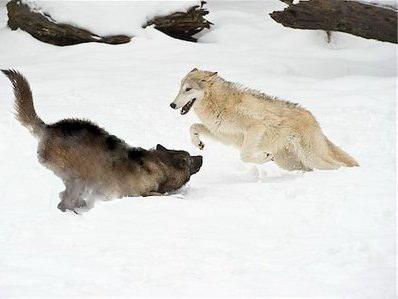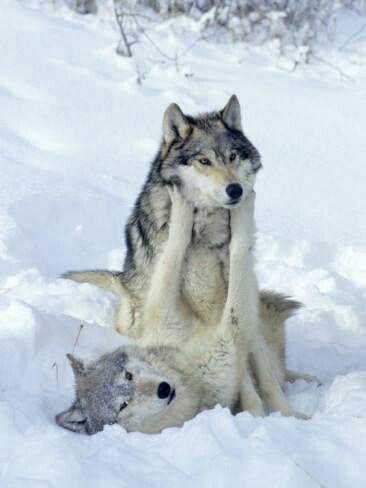The first image is the image on the left, the second image is the image on the right. Considering the images on both sides, is "Two dogs are standing in the snow in the image on the right." valid? Answer yes or no. No. The first image is the image on the left, the second image is the image on the right. Evaluate the accuracy of this statement regarding the images: "An image shows exactly two different colored wolves interacting playfully in the snow, one with its rear toward the camera.". Is it true? Answer yes or no. Yes. 